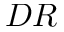Convert formula to latex. <formula><loc_0><loc_0><loc_500><loc_500>D R</formula> 